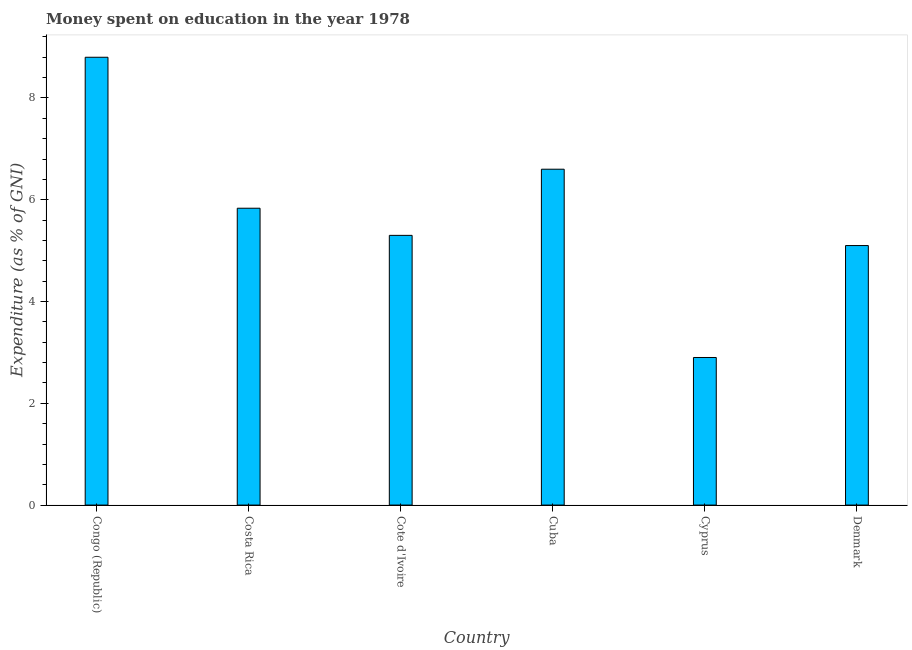Does the graph contain grids?
Your answer should be very brief. No. What is the title of the graph?
Make the answer very short. Money spent on education in the year 1978. What is the label or title of the X-axis?
Offer a terse response. Country. What is the label or title of the Y-axis?
Offer a terse response. Expenditure (as % of GNI). Across all countries, what is the minimum expenditure on education?
Your response must be concise. 2.9. In which country was the expenditure on education maximum?
Your answer should be very brief. Congo (Republic). In which country was the expenditure on education minimum?
Provide a succinct answer. Cyprus. What is the sum of the expenditure on education?
Keep it short and to the point. 34.53. What is the average expenditure on education per country?
Offer a very short reply. 5.76. What is the median expenditure on education?
Provide a short and direct response. 5.57. In how many countries, is the expenditure on education greater than 5.2 %?
Your answer should be very brief. 4. What is the ratio of the expenditure on education in Costa Rica to that in Cuba?
Your answer should be very brief. 0.88. Is the difference between the expenditure on education in Congo (Republic) and Cyprus greater than the difference between any two countries?
Your answer should be very brief. Yes. What is the difference between the highest and the lowest expenditure on education?
Offer a very short reply. 5.9. How many countries are there in the graph?
Your answer should be compact. 6. Are the values on the major ticks of Y-axis written in scientific E-notation?
Provide a succinct answer. No. What is the Expenditure (as % of GNI) in Congo (Republic)?
Your response must be concise. 8.8. What is the Expenditure (as % of GNI) in Costa Rica?
Provide a succinct answer. 5.83. What is the Expenditure (as % of GNI) of Cyprus?
Make the answer very short. 2.9. What is the difference between the Expenditure (as % of GNI) in Congo (Republic) and Costa Rica?
Keep it short and to the point. 2.97. What is the difference between the Expenditure (as % of GNI) in Congo (Republic) and Cote d'Ivoire?
Provide a succinct answer. 3.5. What is the difference between the Expenditure (as % of GNI) in Congo (Republic) and Cyprus?
Offer a terse response. 5.9. What is the difference between the Expenditure (as % of GNI) in Costa Rica and Cote d'Ivoire?
Your response must be concise. 0.53. What is the difference between the Expenditure (as % of GNI) in Costa Rica and Cuba?
Your answer should be very brief. -0.77. What is the difference between the Expenditure (as % of GNI) in Costa Rica and Cyprus?
Offer a very short reply. 2.93. What is the difference between the Expenditure (as % of GNI) in Costa Rica and Denmark?
Your response must be concise. 0.73. What is the difference between the Expenditure (as % of GNI) in Cote d'Ivoire and Cuba?
Offer a very short reply. -1.3. What is the difference between the Expenditure (as % of GNI) in Cote d'Ivoire and Denmark?
Provide a succinct answer. 0.2. What is the difference between the Expenditure (as % of GNI) in Cuba and Cyprus?
Your answer should be compact. 3.7. What is the difference between the Expenditure (as % of GNI) in Cuba and Denmark?
Your response must be concise. 1.5. What is the difference between the Expenditure (as % of GNI) in Cyprus and Denmark?
Provide a short and direct response. -2.2. What is the ratio of the Expenditure (as % of GNI) in Congo (Republic) to that in Costa Rica?
Give a very brief answer. 1.51. What is the ratio of the Expenditure (as % of GNI) in Congo (Republic) to that in Cote d'Ivoire?
Ensure brevity in your answer.  1.66. What is the ratio of the Expenditure (as % of GNI) in Congo (Republic) to that in Cuba?
Give a very brief answer. 1.33. What is the ratio of the Expenditure (as % of GNI) in Congo (Republic) to that in Cyprus?
Keep it short and to the point. 3.03. What is the ratio of the Expenditure (as % of GNI) in Congo (Republic) to that in Denmark?
Give a very brief answer. 1.73. What is the ratio of the Expenditure (as % of GNI) in Costa Rica to that in Cote d'Ivoire?
Your response must be concise. 1.1. What is the ratio of the Expenditure (as % of GNI) in Costa Rica to that in Cuba?
Your response must be concise. 0.88. What is the ratio of the Expenditure (as % of GNI) in Costa Rica to that in Cyprus?
Keep it short and to the point. 2.01. What is the ratio of the Expenditure (as % of GNI) in Costa Rica to that in Denmark?
Give a very brief answer. 1.14. What is the ratio of the Expenditure (as % of GNI) in Cote d'Ivoire to that in Cuba?
Your answer should be very brief. 0.8. What is the ratio of the Expenditure (as % of GNI) in Cote d'Ivoire to that in Cyprus?
Provide a succinct answer. 1.83. What is the ratio of the Expenditure (as % of GNI) in Cote d'Ivoire to that in Denmark?
Ensure brevity in your answer.  1.04. What is the ratio of the Expenditure (as % of GNI) in Cuba to that in Cyprus?
Offer a terse response. 2.28. What is the ratio of the Expenditure (as % of GNI) in Cuba to that in Denmark?
Keep it short and to the point. 1.29. What is the ratio of the Expenditure (as % of GNI) in Cyprus to that in Denmark?
Your answer should be very brief. 0.57. 